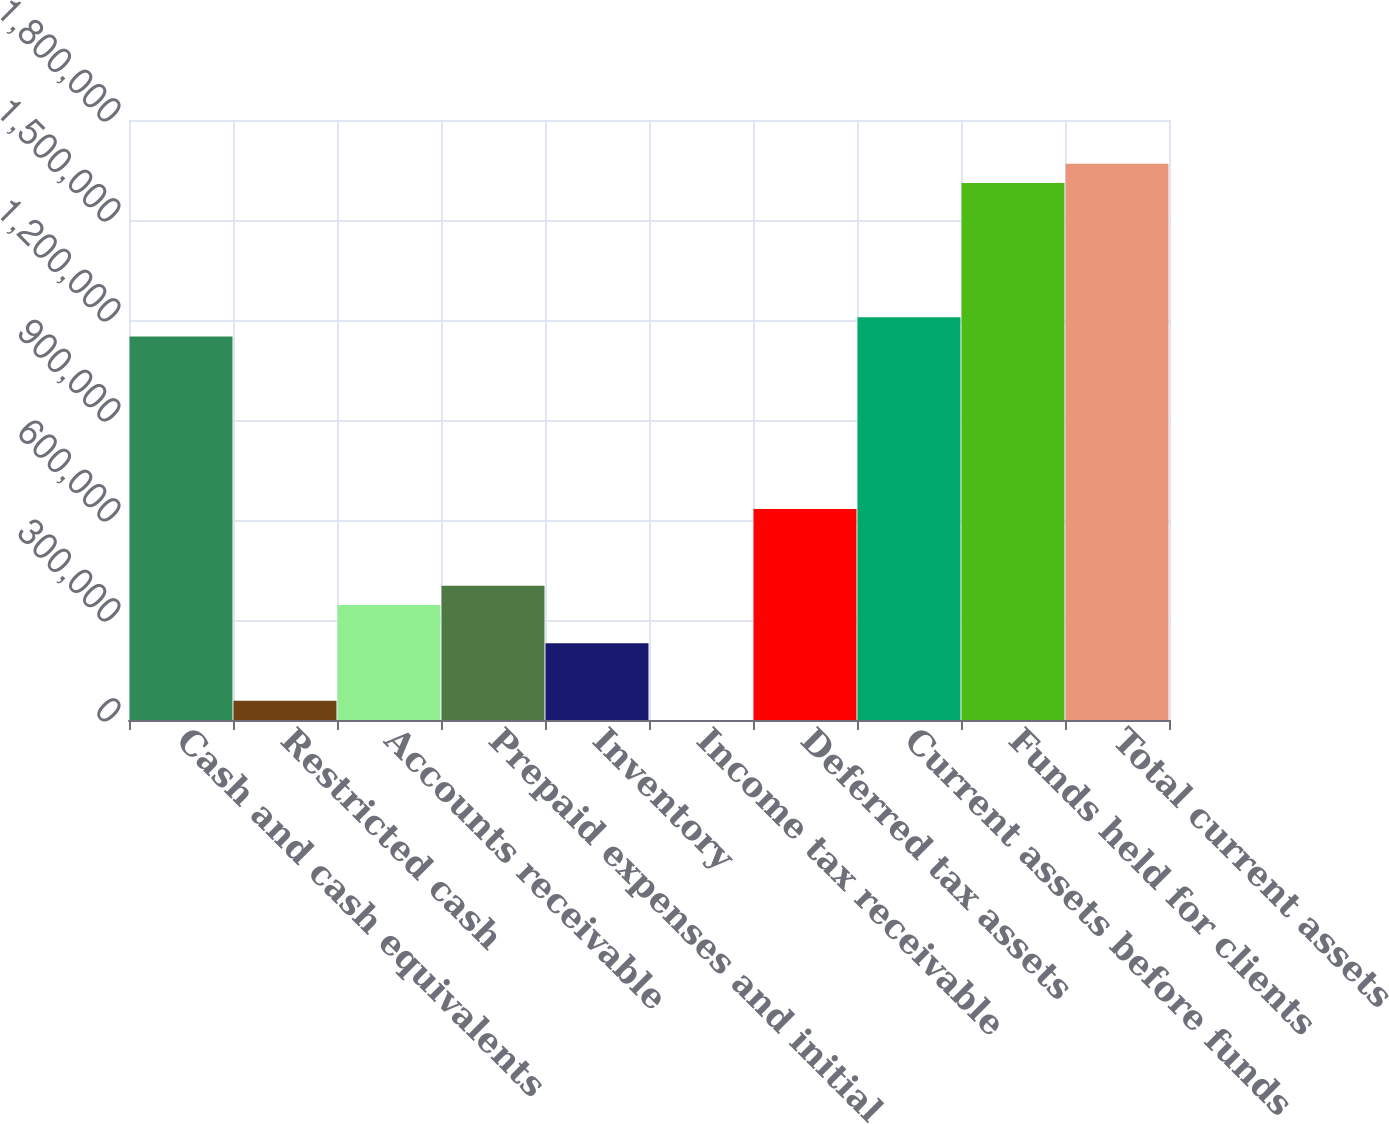Convert chart. <chart><loc_0><loc_0><loc_500><loc_500><bar_chart><fcel>Cash and cash equivalents<fcel>Restricted cash<fcel>Accounts receivable<fcel>Prepaid expenses and initial<fcel>Inventory<fcel>Income tax receivable<fcel>Deferred tax assets<fcel>Current assets before funds<fcel>Funds held for clients<fcel>Total current assets<nl><fcel>1.15081e+06<fcel>57682.8<fcel>345347<fcel>402880<fcel>230281<fcel>150<fcel>633011<fcel>1.20834e+06<fcel>1.61107e+06<fcel>1.6686e+06<nl></chart> 